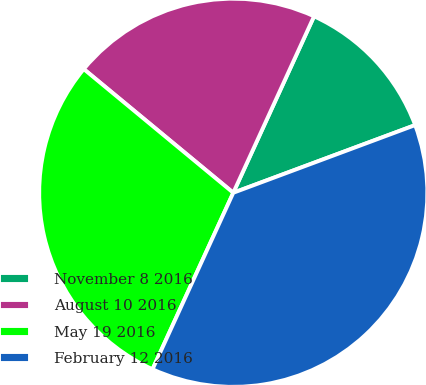<chart> <loc_0><loc_0><loc_500><loc_500><pie_chart><fcel>November 8 2016<fcel>August 10 2016<fcel>May 19 2016<fcel>February 12 2016<nl><fcel>12.5%<fcel>20.83%<fcel>29.17%<fcel>37.5%<nl></chart> 